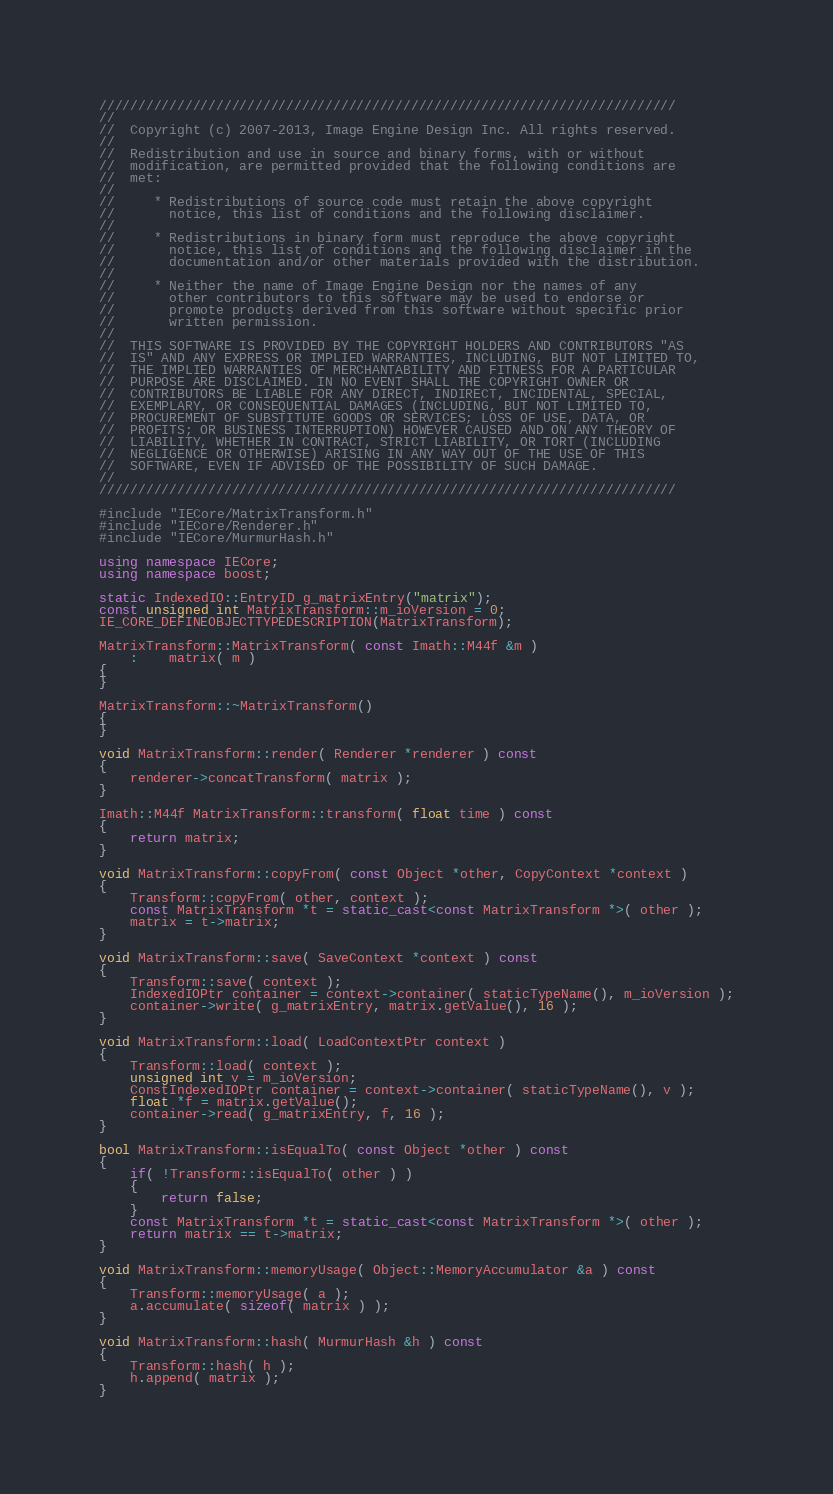Convert code to text. <code><loc_0><loc_0><loc_500><loc_500><_C++_>//////////////////////////////////////////////////////////////////////////
//
//  Copyright (c) 2007-2013, Image Engine Design Inc. All rights reserved.
//
//  Redistribution and use in source and binary forms, with or without
//  modification, are permitted provided that the following conditions are
//  met:
//
//     * Redistributions of source code must retain the above copyright
//       notice, this list of conditions and the following disclaimer.
//
//     * Redistributions in binary form must reproduce the above copyright
//       notice, this list of conditions and the following disclaimer in the
//       documentation and/or other materials provided with the distribution.
//
//     * Neither the name of Image Engine Design nor the names of any
//       other contributors to this software may be used to endorse or
//       promote products derived from this software without specific prior
//       written permission.
//
//  THIS SOFTWARE IS PROVIDED BY THE COPYRIGHT HOLDERS AND CONTRIBUTORS "AS
//  IS" AND ANY EXPRESS OR IMPLIED WARRANTIES, INCLUDING, BUT NOT LIMITED TO,
//  THE IMPLIED WARRANTIES OF MERCHANTABILITY AND FITNESS FOR A PARTICULAR
//  PURPOSE ARE DISCLAIMED. IN NO EVENT SHALL THE COPYRIGHT OWNER OR
//  CONTRIBUTORS BE LIABLE FOR ANY DIRECT, INDIRECT, INCIDENTAL, SPECIAL,
//  EXEMPLARY, OR CONSEQUENTIAL DAMAGES (INCLUDING, BUT NOT LIMITED TO,
//  PROCUREMENT OF SUBSTITUTE GOODS OR SERVICES; LOSS OF USE, DATA, OR
//  PROFITS; OR BUSINESS INTERRUPTION) HOWEVER CAUSED AND ON ANY THEORY OF
//  LIABILITY, WHETHER IN CONTRACT, STRICT LIABILITY, OR TORT (INCLUDING
//  NEGLIGENCE OR OTHERWISE) ARISING IN ANY WAY OUT OF THE USE OF THIS
//  SOFTWARE, EVEN IF ADVISED OF THE POSSIBILITY OF SUCH DAMAGE.
//
//////////////////////////////////////////////////////////////////////////

#include "IECore/MatrixTransform.h"
#include "IECore/Renderer.h"
#include "IECore/MurmurHash.h"

using namespace IECore;
using namespace boost;

static IndexedIO::EntryID g_matrixEntry("matrix");
const unsigned int MatrixTransform::m_ioVersion = 0;
IE_CORE_DEFINEOBJECTTYPEDESCRIPTION(MatrixTransform);

MatrixTransform::MatrixTransform( const Imath::M44f &m )
	:	matrix( m )
{
}

MatrixTransform::~MatrixTransform()
{
}

void MatrixTransform::render( Renderer *renderer ) const
{
	renderer->concatTransform( matrix );
}

Imath::M44f MatrixTransform::transform( float time ) const
{
	return matrix;
}

void MatrixTransform::copyFrom( const Object *other, CopyContext *context )
{
	Transform::copyFrom( other, context );
	const MatrixTransform *t = static_cast<const MatrixTransform *>( other );
	matrix = t->matrix;
}

void MatrixTransform::save( SaveContext *context ) const
{
	Transform::save( context );
	IndexedIOPtr container = context->container( staticTypeName(), m_ioVersion );
	container->write( g_matrixEntry, matrix.getValue(), 16 );
}

void MatrixTransform::load( LoadContextPtr context )
{
	Transform::load( context );
	unsigned int v = m_ioVersion;
	ConstIndexedIOPtr container = context->container( staticTypeName(), v );
	float *f = matrix.getValue();
	container->read( g_matrixEntry, f, 16 );
}

bool MatrixTransform::isEqualTo( const Object *other ) const
{
	if( !Transform::isEqualTo( other ) )
	{
		return false;
	}
	const MatrixTransform *t = static_cast<const MatrixTransform *>( other );
	return matrix == t->matrix;
}

void MatrixTransform::memoryUsage( Object::MemoryAccumulator &a ) const
{
	Transform::memoryUsage( a );
	a.accumulate( sizeof( matrix ) );
}

void MatrixTransform::hash( MurmurHash &h ) const
{
	Transform::hash( h );
	h.append( matrix );
}
</code> 